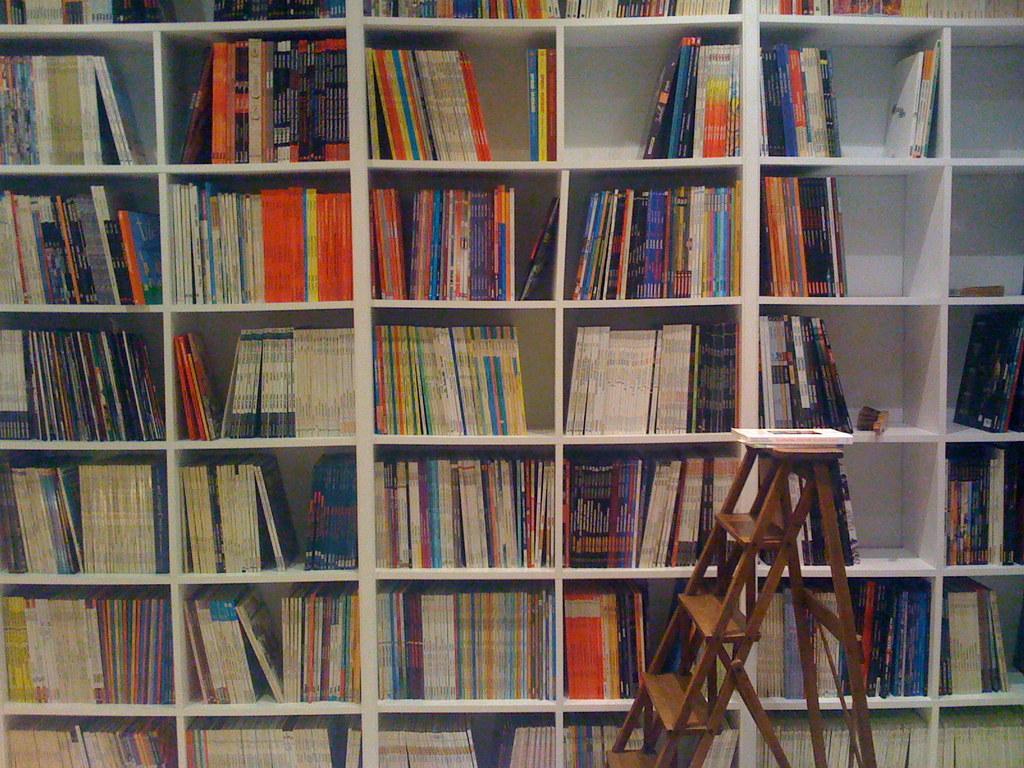In one or two sentences, can you explain what this image depicts? In this image, I can see the books, which are kept in the book shelves. I think this is the ladder with a book on it. 